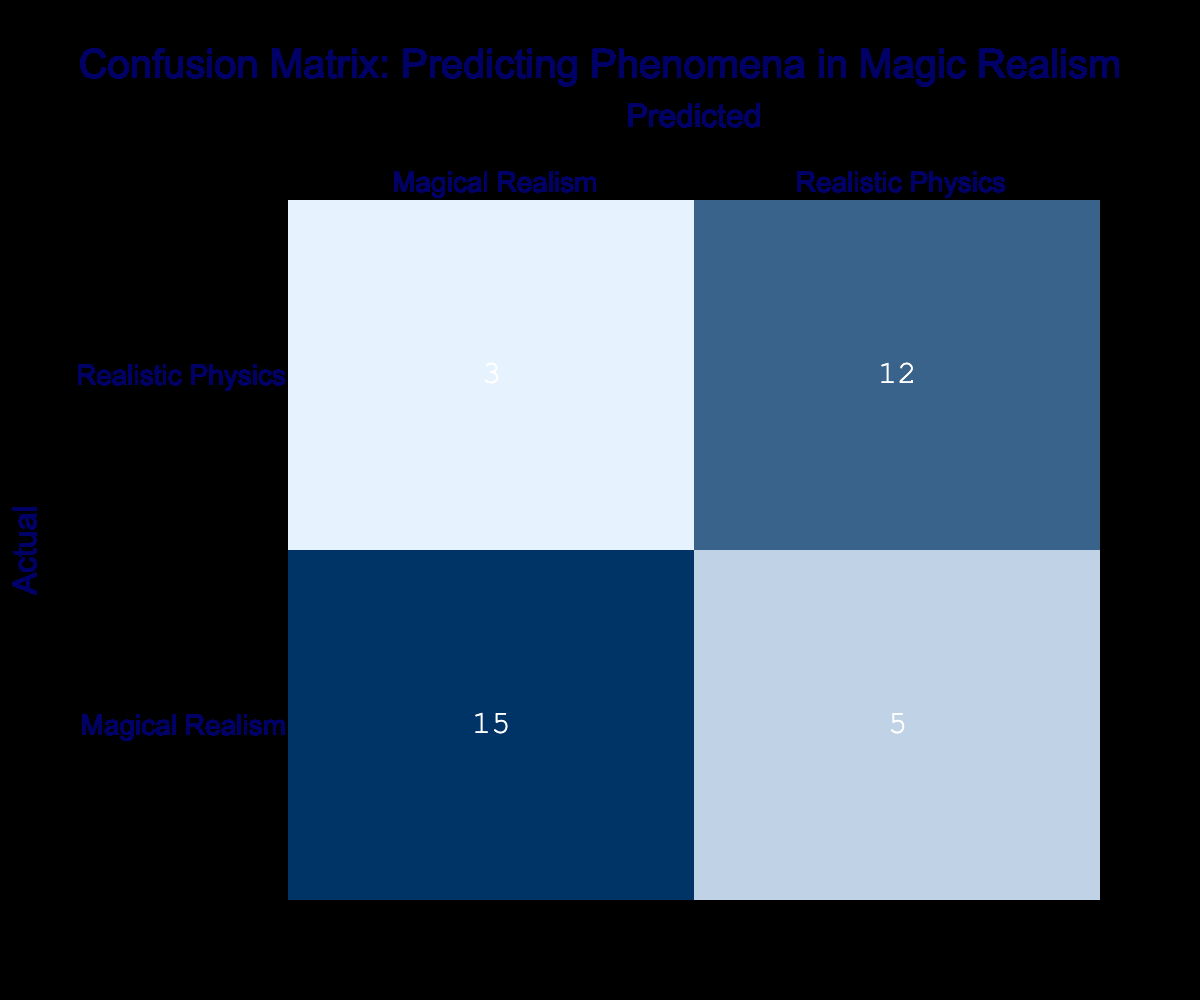What is the total number of predictions for Magical Realism? From the confusion matrix, we can see that the total predictions for Magical Realism consist of 15 true positives (predicted as Magical Realism and actually Magical Realism) and 5 false negatives (predicted as Realistic Physics but actually Magical Realism). Therefore, the total is 15 + 5 = 20.
Answer: 20 How many instances were accurately predicted as Realistic Physics? The instances accurately predicted as Realistic Physics can be found in the confusion matrix as true negatives. This value is given directly in the table as 12.
Answer: 12 What is the total number of predictions made? To find the total predictions made, we can sum all values in the confusion matrix: (15 + 5) for Magical Realism and (3 + 12) for Realistic Physics, resulting in 15 + 5 + 3 + 12 = 35.
Answer: 35 How many instances were incorrectly classified as Magical Realism? The incorrect classifications as Magical Realism consist of false positives, which are shown in the confusion matrix as 3. These represent instances that were actually Realistic Physics but predicted as Magical Realism.
Answer: 3 What is the overall accuracy of the model? Accuracy is calculated as the sum of true positives and true negatives divided by the total number of instances. Using the values from the matrix, we calculate it as (15 + 12) / (15 + 5 + 3 + 12) = 27 / 35, which approximately equals 0.771, or 77.1%.
Answer: 77.1% Is the number of false negatives greater than the number of false positives? From the confusion matrix, the number of false negatives is 5 and false positives is 3. Since 5 is greater than 3, the statement is true.
Answer: Yes How many more correct predictions were made for Magical Realism than for Realistic Physics? To find this, we look at the true positives for Magical Realism (15) and true positives for Realistic Physics (12). The difference is 15 - 12 = 3, indicating there were 3 more correct predictions for Magical Realism.
Answer: 3 What percentage of the predictions were incorrectly classified as Realistic Physics? To determine this, we need the number of incorrect predictions for Realistic Physics. The false negatives are 5 and false positives are 3, totaling 8 incorrect predictions. The percentage is calculated as (8 / 35) * 100, which is approximately 22.86%.
Answer: 22.86% 